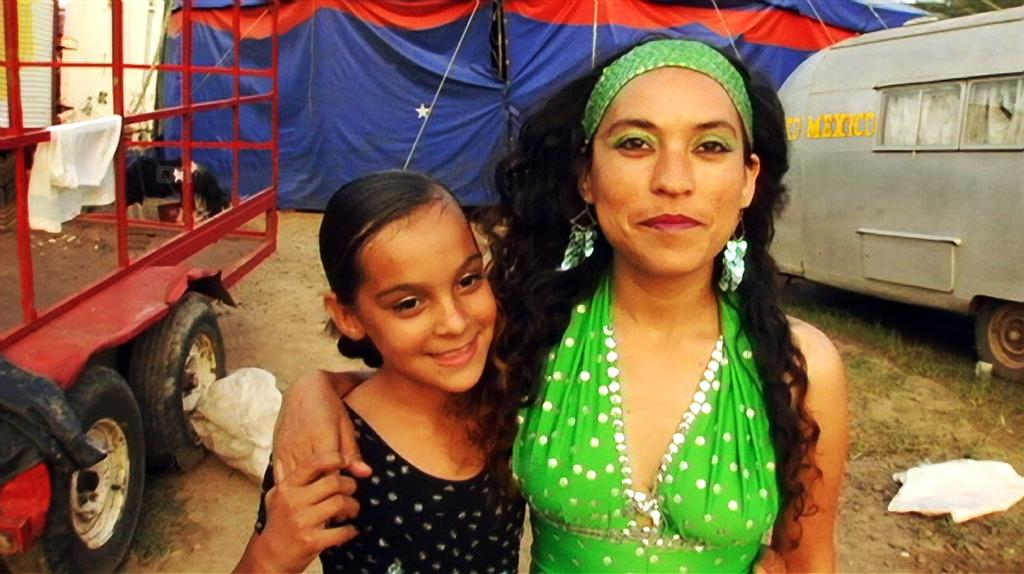Who can be seen in the image? There is a lady and a girl in the image. What are the lady and the girl doing in the image? Both the lady and the girl are standing and smiling. What else can be seen in the image besides the lady and the girl? There are vehicles visible in the image, as well as a tent in the background and grass at the bottom. What song is being sung by the lady and the girl in the image? There is no indication in the image that the lady and the girl are singing a song, so it cannot be determined from the picture. 